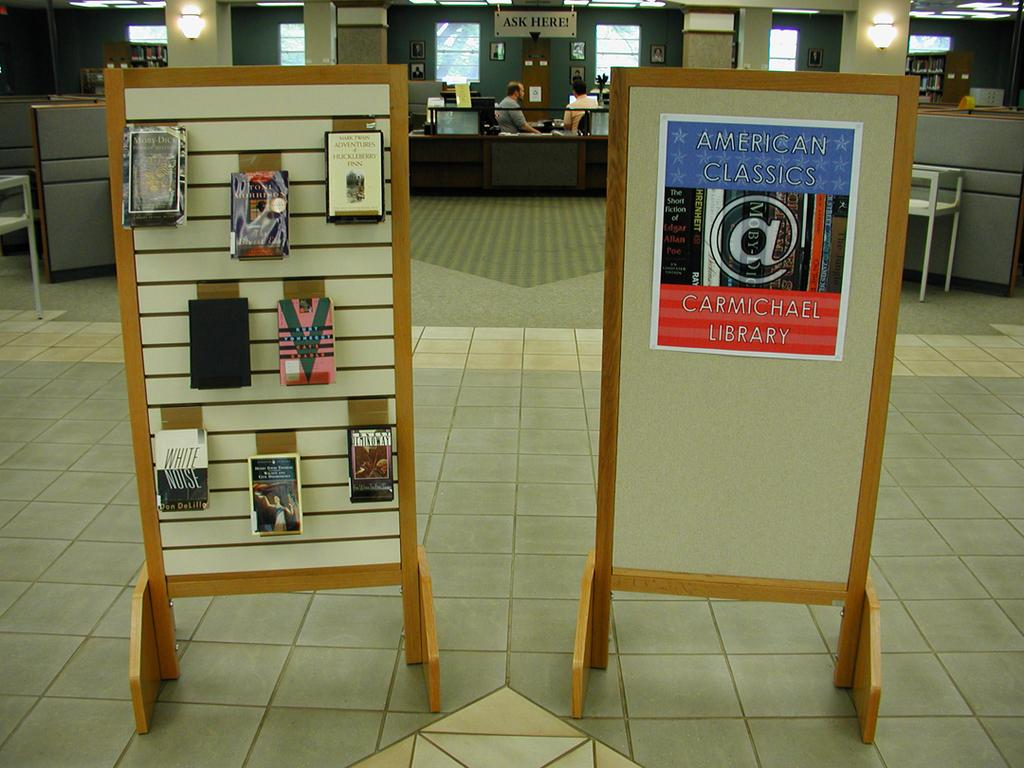<image>
Create a compact narrative representing the image presented. A poster sign that says Carmichael Library on a display board 